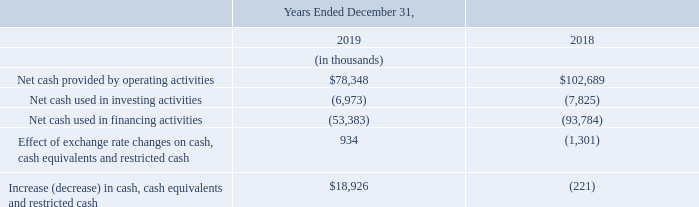Following is a summary of our cash flows provided by (used in) operating activities, investing activities and financing activities for the years endedD ecember 31, 2019 and 2018. A discussion of cash flows for the year ended December 31, 2017 has been omitted from this Annual Report on Form 10-K, but may be found in “Item 7.
Management’s Discussion and Analysis of Financial Condition and Results of Operations,” under the heading “Liquidity and Capital Resources” in our Annual Report on Form 10-K for the year ended December 31, 2018, filed with the SEC on February 5, 2019, which discussion is incorporated herein by reference and which is available free of charge on the SEC’s website at www.sec.gov.
Cash Flows from Operating Activities
Net cash provided by operating activities was $78.3 million for the year ended December 31, 2019. Net cash provided by operating activities consisted of positive cash flow from operations including $101.1 million in non-cash expenses and $16.9 million in changes in operating assets and liabilities, partially offset by net loss of $19.9 million and deferred income taxes and excess tax benefits from stock-based compensation of $19.8 million.
Non-cash items included in net loss for the year ended December 31, 2019 primarily included depreciation and amortization of property, equipment, intangible assets and leased right-of-use assets of $66.4 million and stock-based compensation of $32.1 million.
During the year ended December 31, 2019, we also exited certain leased facilities, which resulted in impairment of leased right-of-use assets of$ 9.2 million and leasehold improvements of $1.4 million, which was partially offset by a gain on extinguishment of related lease liabilities of$ 10.4 million, all of which are non-cash items that did not affect cash flows.
Net cash provided by operating activities was $102.7 million for the year ended December 31, 2018. Net cash provided by operating activities consisted of positive cash flow from operations including $100.3 million in non-cash operating expenses and $28.6 million in changes in operating assets and liabilities, partially offset by net loss of $26.2 million.
Non-cash items included in net loss for the year ended December 31, 2018 primarily included depreciation and amortization of property, equipment and intangible assets of $79.0 million, stock-based compensation of $31.7 million, and impairment of intangible assets of $2.2 million, partially offset by deferred income taxes of $12.1 million and excess tax benefits on stock-based awards of $2.0 million.
Cash Flows from Investing Activities
Net cash used in investing activities was $7.0 million for the year ended December 31, 2019. Net cash used in investing activities primarily consisted of $6.9 million in purchases of property and equipment. Net cash used in investing activities was $7.8 million for the year ended December 31, 2018. Net cash used in investing activities consisted entirely of $7.8 million in purchases of property and equipment.
Cash Flows from Financing Activities
Net cash used in financing activities was $53.4 million for the year ended December 31, 2019. Net cash used in financing activities consisted primarily of cash outflows from aggregate prepayments of principal of $50.0 million and $12.0 million in minimum tax withholding paid on behalf of employees for restricted stock units, partially offset by cash inflows of $8.6 million in net proceeds from issuance of common stock upon exercise of stock options.
Net cash used in financing activities was $93.8 million for the year ended December 31, 2018. Net cash used in financing activities primarily consisted of cash outflows from $93.0 million in aggregate prepayments of principal on outstanding debt and $7.6 million in minimum tax withholding paid on behalf of employees for restricted stock units, partially offset by cash inflows of $6.8 million in net proceeds from issuance of common stock upon exercise of stock options.
We believe that our $92.7 million of cash and cash equivalents at December 31, 2019 will be sufficient to fund our projected operating requirements for at least the next twelve months. We have repaid $213.0 million of debt to date. The credit agreement permits the Company to request incremental loans in an aggregate principal amount not to exceed the sum of $160.0 million (subject to adjustments for any voluntary prepayments), plus an unlimited amount that is subject to pro forma compliance with certain secured leverage ratio and total leverage ratio tests.
Incremental loans are subject to certain additional conditions, including obtaining additional commitments from the lenders then party to the credit agreement or new lenders. The term loan facility has a seven-year term and bears interest at either an Adjusted LIBOR or an Adjusted Base Rate, at our option, plus a fixed applicable margin.
Our cash and cash equivalents in recent years have been favorably affected by our implementation of an equity-based bonus program for our employees, including executives. In connection with that bonus program, in February 2019, we issued 0.3 million freely-tradable shares of our common stock in settlement of bonus awards for the 2018 performance period. We expect to implement a similar equity-based plan for fiscal 2019, but our compensation committee retains discretion to effect payment in cash, stock, or a combination of cash and stock.
Notwithstanding the foregoing, we may need to raise additional capital or incur additional indebtedness to fund strategic initiatives or operating activities, particularly if we continue to pursue acquisitions.
Our future capital requirements will depend on many factors, including our rate of revenue growth, the expansion of our engineering, sales and marketing activities, the timing and extent of our expansion into new territories, the timing of introductions of new products and enhancements to existing products, the continuing market acceptance of our products and potential material investments in, or acquisitions of, complementary businesses, services or technologies. Additional funds may not be available on terms favorable to us or at all.
If we are unable to raise additional funds when needed, we may not be able to sustain our operations or execute our strategic plans.
How much was the Net cash used in financing activities for the year ended December 31, 2018? $93.8 million. What is the average Net cash provided by operating activities for the year ended December 31, 2019 to 2018?
Answer scale should be: thousand. (78,348+102,689) / 2
Answer: 90518.5. What is the average Net cash used in investing activities for the year ended December 31, 2019 to 2018?
Answer scale should be: thousand. (6,973+7,825) / 2
Answer: 7399. In which year was Net cash provided by operating activities less than 80,000 thousands? Locate and analyze net cash provided by operating activities in row 4
answer: 2019. What was the respective Net cash used in investing activities in 2019 and 2018?
Answer scale should be: thousand. (6,973), (7,825). When was the Form 10-K for the year ended December 31, 2018, filed with the SEC? February 5, 2019. 